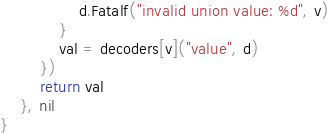<code> <loc_0><loc_0><loc_500><loc_500><_Go_>				d.Fatalf("invalid union value: %d", v)
			}
			val = decoders[v]("value", d)
		})
		return val
	}, nil
}
</code> 